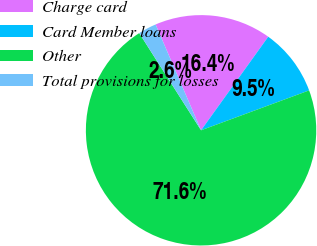<chart> <loc_0><loc_0><loc_500><loc_500><pie_chart><fcel>Charge card<fcel>Card Member loans<fcel>Other<fcel>Total provisions for losses<nl><fcel>16.37%<fcel>9.46%<fcel>71.61%<fcel>2.56%<nl></chart> 